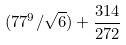Convert formula to latex. <formula><loc_0><loc_0><loc_500><loc_500>( 7 7 ^ { 9 } / \sqrt { 6 } ) + \frac { 3 1 4 } { 2 7 2 }</formula> 